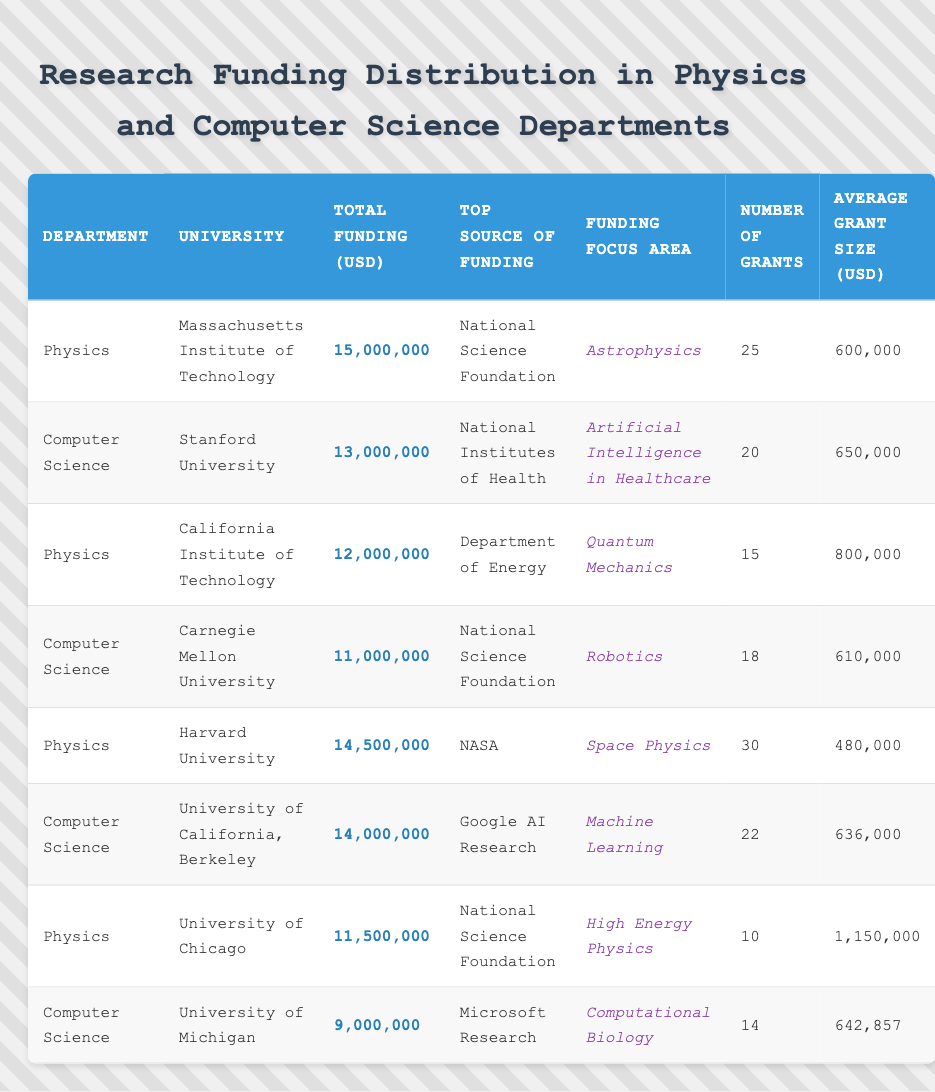What is the total funding received by the University of Chicago's Physics department? The table shows that the University of Chicago received a total funding of 11,500,000 USD in the Physics department.
Answer: 11,500,000 USD Which university has the highest total funding for its Computer Science department? By comparing the total funding amounts in the Computer Science department, University of California, Berkeley has the highest total funding of 14,000,000 USD.
Answer: University of California, Berkeley What is the average grant size in the Physics department at Harvard University? The average grant size listed for Harvard University's Physics department is 480,000 USD.
Answer: 480,000 USD How many grants were awarded to the Computer Science department at Stanford University? According to the table, Stanford University's Computer Science department was awarded 20 grants.
Answer: 20 grants Is the top source of funding for the Physics department at MIT the National Science Foundation? The table indicates that the top source of funding for MIT's Physics department is indeed the National Science Foundation, confirming the statement.
Answer: Yes What is the difference in total funding between the Physics department at Caltech and the Computer Science department at Carnegie Mellon University? The total funding for Caltech's Physics department is 12,000,000 USD, while Carnegie Mellon's Computer Science department has 11,000,000 USD. The difference is 12,000,000 - 11,000,000 = 1,000,000 USD.
Answer: 1,000,000 USD What is the average number of grants awarded in the Computer Science departments across all universities listed? The total number of grants for Computer Science departments are 20, 18, 22, and 14, which sum up to 74. There are 4 departments, so the average number of grants is 74 / 4 = 18.5.
Answer: 18.5 grants Which department received the highest average grant size, and what was that amount? Calculating the average grant size involves dividing total funding by the number of grants for each department. Physics at University of Chicago has an average grant size of 1,150,000 USD, while others in Physics and Computer Science have lower amounts. Thus, Physics at the University of Chicago received the highest average grant size.
Answer: Physics at University of Chicago, 1,150,000 USD How much total funding was awarded to the Physics departments across all universities? The total funding amounts for Physics departments are summed: 15,000,000 + 12,000,000 + 14,500,000 + 11,500,000 = 53,000,000 USD.
Answer: 53,000,000 USD What percentage of total funding for Computer Science departments comes from the top source of funding listed? The total funding for Computer Science departments is 13,000,000 + 11,000,000 + 14,000,000 + 9,000,000 = 47,000,000 USD. The top source of funding for these departments (National Institutes of Health and National Science Foundation) sums to 13,000,000 + 11,000,000 = 24,000,000 USD, which is 24,000,000 / 47,000,000 * 100 = 51.06%.
Answer: Approximately 51.06% 